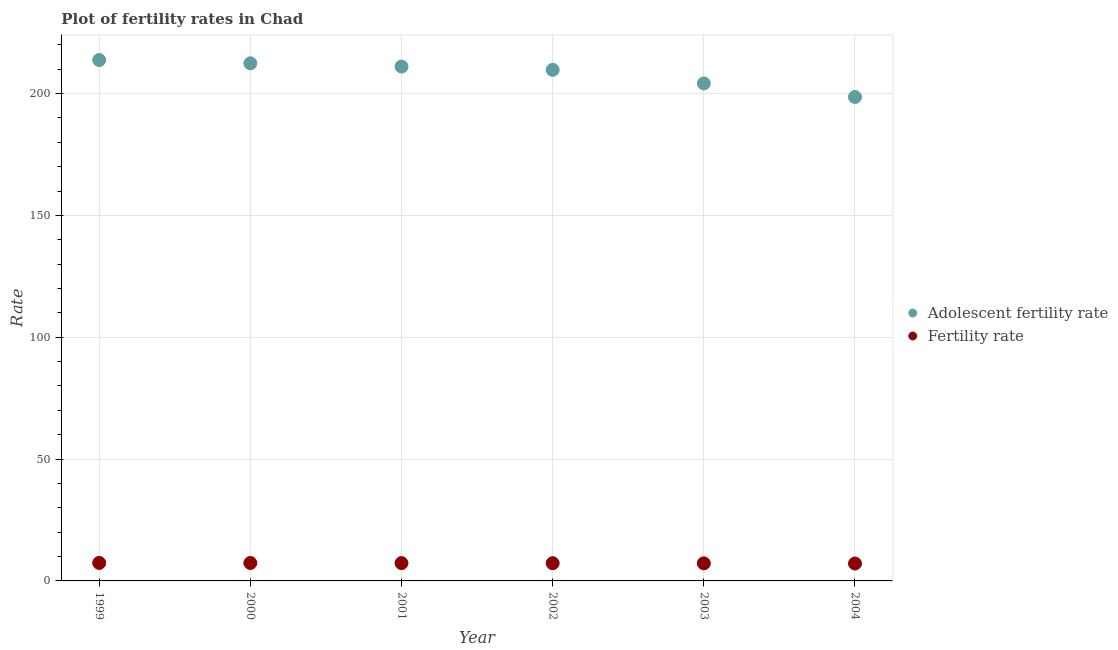How many different coloured dotlines are there?
Keep it short and to the point. 2. Is the number of dotlines equal to the number of legend labels?
Your response must be concise. Yes. What is the fertility rate in 1999?
Provide a succinct answer. 7.38. Across all years, what is the maximum adolescent fertility rate?
Your answer should be compact. 213.75. Across all years, what is the minimum fertility rate?
Provide a short and direct response. 7.15. In which year was the fertility rate maximum?
Your response must be concise. 1999. In which year was the fertility rate minimum?
Make the answer very short. 2004. What is the total fertility rate in the graph?
Your answer should be very brief. 43.68. What is the difference between the fertility rate in 2000 and that in 2003?
Ensure brevity in your answer.  0.14. What is the difference between the fertility rate in 2003 and the adolescent fertility rate in 2002?
Offer a very short reply. -202.52. What is the average adolescent fertility rate per year?
Provide a succinct answer. 208.28. In the year 1999, what is the difference between the adolescent fertility rate and fertility rate?
Keep it short and to the point. 206.37. In how many years, is the adolescent fertility rate greater than 120?
Offer a terse response. 6. What is the ratio of the fertility rate in 2000 to that in 2003?
Your response must be concise. 1.02. Is the fertility rate in 2001 less than that in 2004?
Give a very brief answer. No. What is the difference between the highest and the second highest adolescent fertility rate?
Give a very brief answer. 1.34. What is the difference between the highest and the lowest adolescent fertility rate?
Offer a terse response. 15.16. In how many years, is the adolescent fertility rate greater than the average adolescent fertility rate taken over all years?
Make the answer very short. 4. Is the sum of the fertility rate in 2002 and 2003 greater than the maximum adolescent fertility rate across all years?
Provide a succinct answer. No. How many dotlines are there?
Your answer should be very brief. 2. How many years are there in the graph?
Offer a very short reply. 6. What is the difference between two consecutive major ticks on the Y-axis?
Ensure brevity in your answer.  50. Does the graph contain grids?
Make the answer very short. Yes. Where does the legend appear in the graph?
Make the answer very short. Center right. How many legend labels are there?
Give a very brief answer. 2. How are the legend labels stacked?
Make the answer very short. Vertical. What is the title of the graph?
Provide a succinct answer. Plot of fertility rates in Chad. Does "Secondary Education" appear as one of the legend labels in the graph?
Provide a succinct answer. No. What is the label or title of the X-axis?
Give a very brief answer. Year. What is the label or title of the Y-axis?
Provide a short and direct response. Rate. What is the Rate in Adolescent fertility rate in 1999?
Your answer should be very brief. 213.75. What is the Rate of Fertility rate in 1999?
Make the answer very short. 7.38. What is the Rate of Adolescent fertility rate in 2000?
Offer a terse response. 212.41. What is the Rate in Fertility rate in 2000?
Provide a succinct answer. 7.35. What is the Rate of Adolescent fertility rate in 2001?
Give a very brief answer. 211.07. What is the Rate of Fertility rate in 2001?
Your answer should be very brief. 7.32. What is the Rate in Adolescent fertility rate in 2002?
Your response must be concise. 209.73. What is the Rate in Fertility rate in 2002?
Ensure brevity in your answer.  7.27. What is the Rate of Adolescent fertility rate in 2003?
Give a very brief answer. 204.16. What is the Rate of Fertility rate in 2003?
Ensure brevity in your answer.  7.21. What is the Rate in Adolescent fertility rate in 2004?
Keep it short and to the point. 198.59. What is the Rate in Fertility rate in 2004?
Offer a terse response. 7.15. Across all years, what is the maximum Rate of Adolescent fertility rate?
Provide a succinct answer. 213.75. Across all years, what is the maximum Rate of Fertility rate?
Your response must be concise. 7.38. Across all years, what is the minimum Rate in Adolescent fertility rate?
Make the answer very short. 198.59. Across all years, what is the minimum Rate of Fertility rate?
Your answer should be compact. 7.15. What is the total Rate of Adolescent fertility rate in the graph?
Your response must be concise. 1249.7. What is the total Rate in Fertility rate in the graph?
Give a very brief answer. 43.68. What is the difference between the Rate in Adolescent fertility rate in 1999 and that in 2000?
Ensure brevity in your answer.  1.34. What is the difference between the Rate in Adolescent fertility rate in 1999 and that in 2001?
Provide a short and direct response. 2.68. What is the difference between the Rate of Fertility rate in 1999 and that in 2001?
Provide a succinct answer. 0.07. What is the difference between the Rate in Adolescent fertility rate in 1999 and that in 2002?
Ensure brevity in your answer.  4.02. What is the difference between the Rate of Fertility rate in 1999 and that in 2002?
Your answer should be compact. 0.12. What is the difference between the Rate in Adolescent fertility rate in 1999 and that in 2003?
Keep it short and to the point. 9.59. What is the difference between the Rate in Fertility rate in 1999 and that in 2003?
Ensure brevity in your answer.  0.17. What is the difference between the Rate in Adolescent fertility rate in 1999 and that in 2004?
Ensure brevity in your answer.  15.16. What is the difference between the Rate in Fertility rate in 1999 and that in 2004?
Provide a short and direct response. 0.24. What is the difference between the Rate of Adolescent fertility rate in 2000 and that in 2001?
Ensure brevity in your answer.  1.34. What is the difference between the Rate in Fertility rate in 2000 and that in 2001?
Your answer should be very brief. 0.04. What is the difference between the Rate of Adolescent fertility rate in 2000 and that in 2002?
Give a very brief answer. 2.68. What is the difference between the Rate in Fertility rate in 2000 and that in 2002?
Your answer should be compact. 0.09. What is the difference between the Rate of Adolescent fertility rate in 2000 and that in 2003?
Make the answer very short. 8.25. What is the difference between the Rate of Fertility rate in 2000 and that in 2003?
Give a very brief answer. 0.14. What is the difference between the Rate in Adolescent fertility rate in 2000 and that in 2004?
Give a very brief answer. 13.82. What is the difference between the Rate in Fertility rate in 2000 and that in 2004?
Make the answer very short. 0.21. What is the difference between the Rate in Adolescent fertility rate in 2001 and that in 2002?
Keep it short and to the point. 1.34. What is the difference between the Rate of Fertility rate in 2001 and that in 2002?
Give a very brief answer. 0.05. What is the difference between the Rate of Adolescent fertility rate in 2001 and that in 2003?
Give a very brief answer. 6.91. What is the difference between the Rate of Fertility rate in 2001 and that in 2003?
Give a very brief answer. 0.1. What is the difference between the Rate in Adolescent fertility rate in 2001 and that in 2004?
Your response must be concise. 12.48. What is the difference between the Rate of Fertility rate in 2001 and that in 2004?
Give a very brief answer. 0.17. What is the difference between the Rate of Adolescent fertility rate in 2002 and that in 2003?
Ensure brevity in your answer.  5.57. What is the difference between the Rate of Fertility rate in 2002 and that in 2003?
Make the answer very short. 0.06. What is the difference between the Rate of Adolescent fertility rate in 2002 and that in 2004?
Keep it short and to the point. 11.14. What is the difference between the Rate of Fertility rate in 2002 and that in 2004?
Your response must be concise. 0.12. What is the difference between the Rate in Adolescent fertility rate in 2003 and that in 2004?
Provide a short and direct response. 5.57. What is the difference between the Rate in Fertility rate in 2003 and that in 2004?
Offer a very short reply. 0.07. What is the difference between the Rate in Adolescent fertility rate in 1999 and the Rate in Fertility rate in 2000?
Make the answer very short. 206.4. What is the difference between the Rate of Adolescent fertility rate in 1999 and the Rate of Fertility rate in 2001?
Your response must be concise. 206.44. What is the difference between the Rate in Adolescent fertility rate in 1999 and the Rate in Fertility rate in 2002?
Keep it short and to the point. 206.48. What is the difference between the Rate in Adolescent fertility rate in 1999 and the Rate in Fertility rate in 2003?
Your answer should be compact. 206.54. What is the difference between the Rate of Adolescent fertility rate in 1999 and the Rate of Fertility rate in 2004?
Provide a short and direct response. 206.6. What is the difference between the Rate in Adolescent fertility rate in 2000 and the Rate in Fertility rate in 2001?
Keep it short and to the point. 205.09. What is the difference between the Rate of Adolescent fertility rate in 2000 and the Rate of Fertility rate in 2002?
Your response must be concise. 205.14. What is the difference between the Rate in Adolescent fertility rate in 2000 and the Rate in Fertility rate in 2003?
Offer a very short reply. 205.2. What is the difference between the Rate in Adolescent fertility rate in 2000 and the Rate in Fertility rate in 2004?
Your answer should be very brief. 205.26. What is the difference between the Rate of Adolescent fertility rate in 2001 and the Rate of Fertility rate in 2002?
Keep it short and to the point. 203.8. What is the difference between the Rate of Adolescent fertility rate in 2001 and the Rate of Fertility rate in 2003?
Provide a short and direct response. 203.86. What is the difference between the Rate in Adolescent fertility rate in 2001 and the Rate in Fertility rate in 2004?
Your response must be concise. 203.92. What is the difference between the Rate in Adolescent fertility rate in 2002 and the Rate in Fertility rate in 2003?
Your response must be concise. 202.52. What is the difference between the Rate of Adolescent fertility rate in 2002 and the Rate of Fertility rate in 2004?
Your answer should be compact. 202.58. What is the difference between the Rate in Adolescent fertility rate in 2003 and the Rate in Fertility rate in 2004?
Give a very brief answer. 197.01. What is the average Rate of Adolescent fertility rate per year?
Provide a short and direct response. 208.28. What is the average Rate in Fertility rate per year?
Give a very brief answer. 7.28. In the year 1999, what is the difference between the Rate in Adolescent fertility rate and Rate in Fertility rate?
Offer a terse response. 206.37. In the year 2000, what is the difference between the Rate of Adolescent fertility rate and Rate of Fertility rate?
Keep it short and to the point. 205.06. In the year 2001, what is the difference between the Rate of Adolescent fertility rate and Rate of Fertility rate?
Make the answer very short. 203.75. In the year 2002, what is the difference between the Rate of Adolescent fertility rate and Rate of Fertility rate?
Ensure brevity in your answer.  202.46. In the year 2003, what is the difference between the Rate in Adolescent fertility rate and Rate in Fertility rate?
Offer a very short reply. 196.95. In the year 2004, what is the difference between the Rate in Adolescent fertility rate and Rate in Fertility rate?
Your answer should be very brief. 191.44. What is the ratio of the Rate in Adolescent fertility rate in 1999 to that in 2001?
Your answer should be compact. 1.01. What is the ratio of the Rate of Fertility rate in 1999 to that in 2001?
Keep it short and to the point. 1.01. What is the ratio of the Rate in Adolescent fertility rate in 1999 to that in 2002?
Give a very brief answer. 1.02. What is the ratio of the Rate in Adolescent fertility rate in 1999 to that in 2003?
Ensure brevity in your answer.  1.05. What is the ratio of the Rate of Fertility rate in 1999 to that in 2003?
Your answer should be compact. 1.02. What is the ratio of the Rate in Adolescent fertility rate in 1999 to that in 2004?
Keep it short and to the point. 1.08. What is the ratio of the Rate of Fertility rate in 1999 to that in 2004?
Make the answer very short. 1.03. What is the ratio of the Rate of Adolescent fertility rate in 2000 to that in 2001?
Your answer should be compact. 1.01. What is the ratio of the Rate in Adolescent fertility rate in 2000 to that in 2002?
Your response must be concise. 1.01. What is the ratio of the Rate in Fertility rate in 2000 to that in 2002?
Your answer should be very brief. 1.01. What is the ratio of the Rate of Adolescent fertility rate in 2000 to that in 2003?
Your answer should be very brief. 1.04. What is the ratio of the Rate of Fertility rate in 2000 to that in 2003?
Your response must be concise. 1.02. What is the ratio of the Rate of Adolescent fertility rate in 2000 to that in 2004?
Offer a terse response. 1.07. What is the ratio of the Rate in Adolescent fertility rate in 2001 to that in 2002?
Your answer should be compact. 1.01. What is the ratio of the Rate of Fertility rate in 2001 to that in 2002?
Provide a succinct answer. 1.01. What is the ratio of the Rate in Adolescent fertility rate in 2001 to that in 2003?
Your answer should be compact. 1.03. What is the ratio of the Rate in Fertility rate in 2001 to that in 2003?
Offer a very short reply. 1.01. What is the ratio of the Rate in Adolescent fertility rate in 2001 to that in 2004?
Provide a short and direct response. 1.06. What is the ratio of the Rate of Fertility rate in 2001 to that in 2004?
Offer a very short reply. 1.02. What is the ratio of the Rate in Adolescent fertility rate in 2002 to that in 2003?
Give a very brief answer. 1.03. What is the ratio of the Rate in Adolescent fertility rate in 2002 to that in 2004?
Your answer should be compact. 1.06. What is the ratio of the Rate in Fertility rate in 2002 to that in 2004?
Provide a succinct answer. 1.02. What is the ratio of the Rate of Adolescent fertility rate in 2003 to that in 2004?
Make the answer very short. 1.03. What is the ratio of the Rate in Fertility rate in 2003 to that in 2004?
Make the answer very short. 1.01. What is the difference between the highest and the second highest Rate of Adolescent fertility rate?
Make the answer very short. 1.34. What is the difference between the highest and the lowest Rate of Adolescent fertility rate?
Offer a very short reply. 15.16. What is the difference between the highest and the lowest Rate in Fertility rate?
Provide a succinct answer. 0.24. 